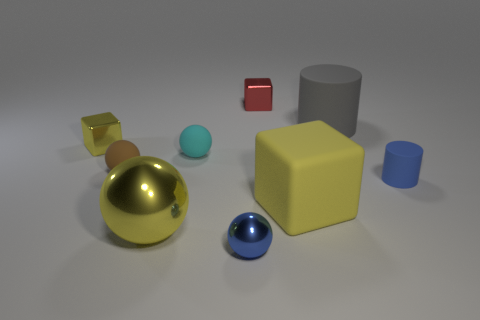How many brown rubber cubes are there?
Ensure brevity in your answer.  0. Are the tiny cyan ball and the small blue cylinder made of the same material?
Your response must be concise. Yes. There is a small matte thing that is on the right side of the big thing to the right of the matte object that is in front of the blue matte thing; what is its shape?
Provide a succinct answer. Cylinder. Are the small object that is in front of the big yellow metallic object and the small red thing that is on the right side of the brown matte object made of the same material?
Give a very brief answer. Yes. What material is the red thing?
Offer a very short reply. Metal. How many other tiny matte things have the same shape as the gray matte object?
Provide a short and direct response. 1. What is the material of the big object that is the same color as the big matte block?
Your response must be concise. Metal. Are there any other things that have the same shape as the tiny blue shiny thing?
Offer a very short reply. Yes. There is a large rubber object that is left of the large matte object behind the yellow cube left of the small blue metal thing; what color is it?
Offer a terse response. Yellow. How many big objects are either yellow blocks or yellow shiny cubes?
Keep it short and to the point. 1. 